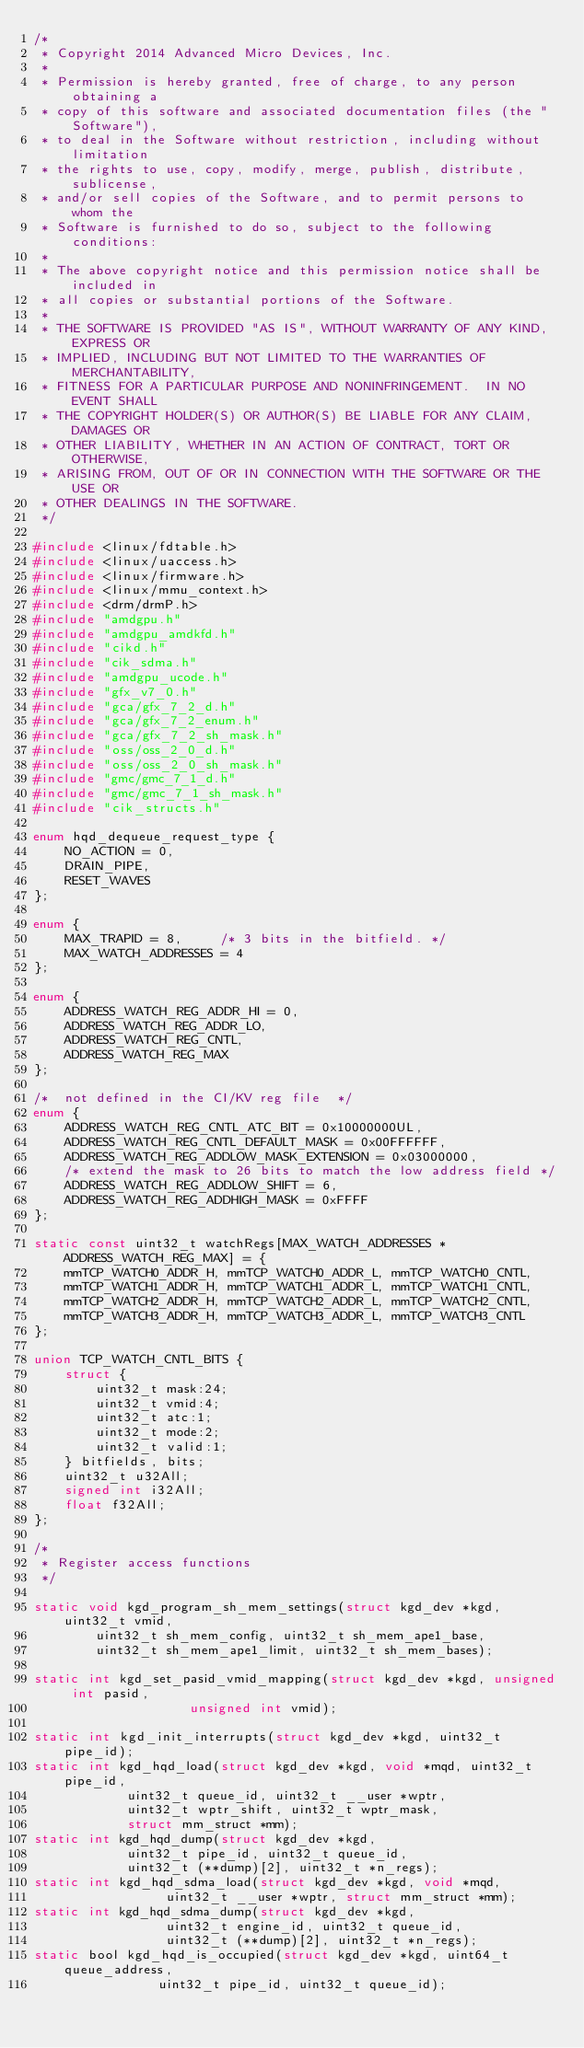<code> <loc_0><loc_0><loc_500><loc_500><_C_>/*
 * Copyright 2014 Advanced Micro Devices, Inc.
 *
 * Permission is hereby granted, free of charge, to any person obtaining a
 * copy of this software and associated documentation files (the "Software"),
 * to deal in the Software without restriction, including without limitation
 * the rights to use, copy, modify, merge, publish, distribute, sublicense,
 * and/or sell copies of the Software, and to permit persons to whom the
 * Software is furnished to do so, subject to the following conditions:
 *
 * The above copyright notice and this permission notice shall be included in
 * all copies or substantial portions of the Software.
 *
 * THE SOFTWARE IS PROVIDED "AS IS", WITHOUT WARRANTY OF ANY KIND, EXPRESS OR
 * IMPLIED, INCLUDING BUT NOT LIMITED TO THE WARRANTIES OF MERCHANTABILITY,
 * FITNESS FOR A PARTICULAR PURPOSE AND NONINFRINGEMENT.  IN NO EVENT SHALL
 * THE COPYRIGHT HOLDER(S) OR AUTHOR(S) BE LIABLE FOR ANY CLAIM, DAMAGES OR
 * OTHER LIABILITY, WHETHER IN AN ACTION OF CONTRACT, TORT OR OTHERWISE,
 * ARISING FROM, OUT OF OR IN CONNECTION WITH THE SOFTWARE OR THE USE OR
 * OTHER DEALINGS IN THE SOFTWARE.
 */

#include <linux/fdtable.h>
#include <linux/uaccess.h>
#include <linux/firmware.h>
#include <linux/mmu_context.h>
#include <drm/drmP.h>
#include "amdgpu.h"
#include "amdgpu_amdkfd.h"
#include "cikd.h"
#include "cik_sdma.h"
#include "amdgpu_ucode.h"
#include "gfx_v7_0.h"
#include "gca/gfx_7_2_d.h"
#include "gca/gfx_7_2_enum.h"
#include "gca/gfx_7_2_sh_mask.h"
#include "oss/oss_2_0_d.h"
#include "oss/oss_2_0_sh_mask.h"
#include "gmc/gmc_7_1_d.h"
#include "gmc/gmc_7_1_sh_mask.h"
#include "cik_structs.h"

enum hqd_dequeue_request_type {
	NO_ACTION = 0,
	DRAIN_PIPE,
	RESET_WAVES
};

enum {
	MAX_TRAPID = 8,		/* 3 bits in the bitfield. */
	MAX_WATCH_ADDRESSES = 4
};

enum {
	ADDRESS_WATCH_REG_ADDR_HI = 0,
	ADDRESS_WATCH_REG_ADDR_LO,
	ADDRESS_WATCH_REG_CNTL,
	ADDRESS_WATCH_REG_MAX
};

/*  not defined in the CI/KV reg file  */
enum {
	ADDRESS_WATCH_REG_CNTL_ATC_BIT = 0x10000000UL,
	ADDRESS_WATCH_REG_CNTL_DEFAULT_MASK = 0x00FFFFFF,
	ADDRESS_WATCH_REG_ADDLOW_MASK_EXTENSION = 0x03000000,
	/* extend the mask to 26 bits to match the low address field */
	ADDRESS_WATCH_REG_ADDLOW_SHIFT = 6,
	ADDRESS_WATCH_REG_ADDHIGH_MASK = 0xFFFF
};

static const uint32_t watchRegs[MAX_WATCH_ADDRESSES * ADDRESS_WATCH_REG_MAX] = {
	mmTCP_WATCH0_ADDR_H, mmTCP_WATCH0_ADDR_L, mmTCP_WATCH0_CNTL,
	mmTCP_WATCH1_ADDR_H, mmTCP_WATCH1_ADDR_L, mmTCP_WATCH1_CNTL,
	mmTCP_WATCH2_ADDR_H, mmTCP_WATCH2_ADDR_L, mmTCP_WATCH2_CNTL,
	mmTCP_WATCH3_ADDR_H, mmTCP_WATCH3_ADDR_L, mmTCP_WATCH3_CNTL
};

union TCP_WATCH_CNTL_BITS {
	struct {
		uint32_t mask:24;
		uint32_t vmid:4;
		uint32_t atc:1;
		uint32_t mode:2;
		uint32_t valid:1;
	} bitfields, bits;
	uint32_t u32All;
	signed int i32All;
	float f32All;
};

/*
 * Register access functions
 */

static void kgd_program_sh_mem_settings(struct kgd_dev *kgd, uint32_t vmid,
		uint32_t sh_mem_config,	uint32_t sh_mem_ape1_base,
		uint32_t sh_mem_ape1_limit, uint32_t sh_mem_bases);

static int kgd_set_pasid_vmid_mapping(struct kgd_dev *kgd, unsigned int pasid,
					unsigned int vmid);

static int kgd_init_interrupts(struct kgd_dev *kgd, uint32_t pipe_id);
static int kgd_hqd_load(struct kgd_dev *kgd, void *mqd, uint32_t pipe_id,
			uint32_t queue_id, uint32_t __user *wptr,
			uint32_t wptr_shift, uint32_t wptr_mask,
			struct mm_struct *mm);
static int kgd_hqd_dump(struct kgd_dev *kgd,
			uint32_t pipe_id, uint32_t queue_id,
			uint32_t (**dump)[2], uint32_t *n_regs);
static int kgd_hqd_sdma_load(struct kgd_dev *kgd, void *mqd,
			     uint32_t __user *wptr, struct mm_struct *mm);
static int kgd_hqd_sdma_dump(struct kgd_dev *kgd,
			     uint32_t engine_id, uint32_t queue_id,
			     uint32_t (**dump)[2], uint32_t *n_regs);
static bool kgd_hqd_is_occupied(struct kgd_dev *kgd, uint64_t queue_address,
				uint32_t pipe_id, uint32_t queue_id);
</code> 